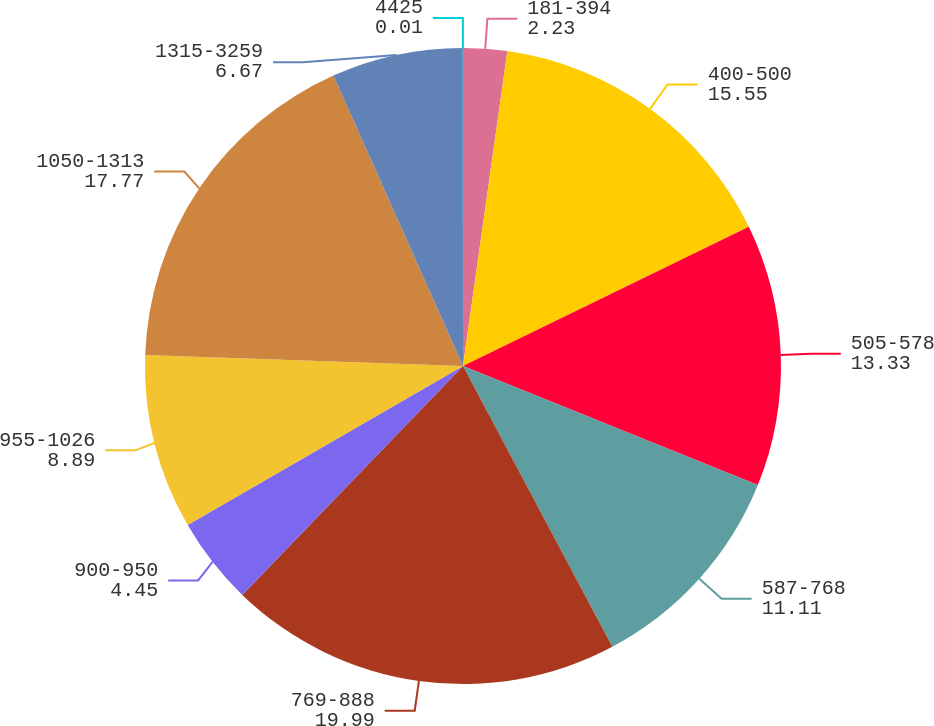<chart> <loc_0><loc_0><loc_500><loc_500><pie_chart><fcel>181-394<fcel>400-500<fcel>505-578<fcel>587-768<fcel>769-888<fcel>900-950<fcel>955-1026<fcel>1050-1313<fcel>1315-3259<fcel>4425<nl><fcel>2.23%<fcel>15.55%<fcel>13.33%<fcel>11.11%<fcel>19.99%<fcel>4.45%<fcel>8.89%<fcel>17.77%<fcel>6.67%<fcel>0.01%<nl></chart> 